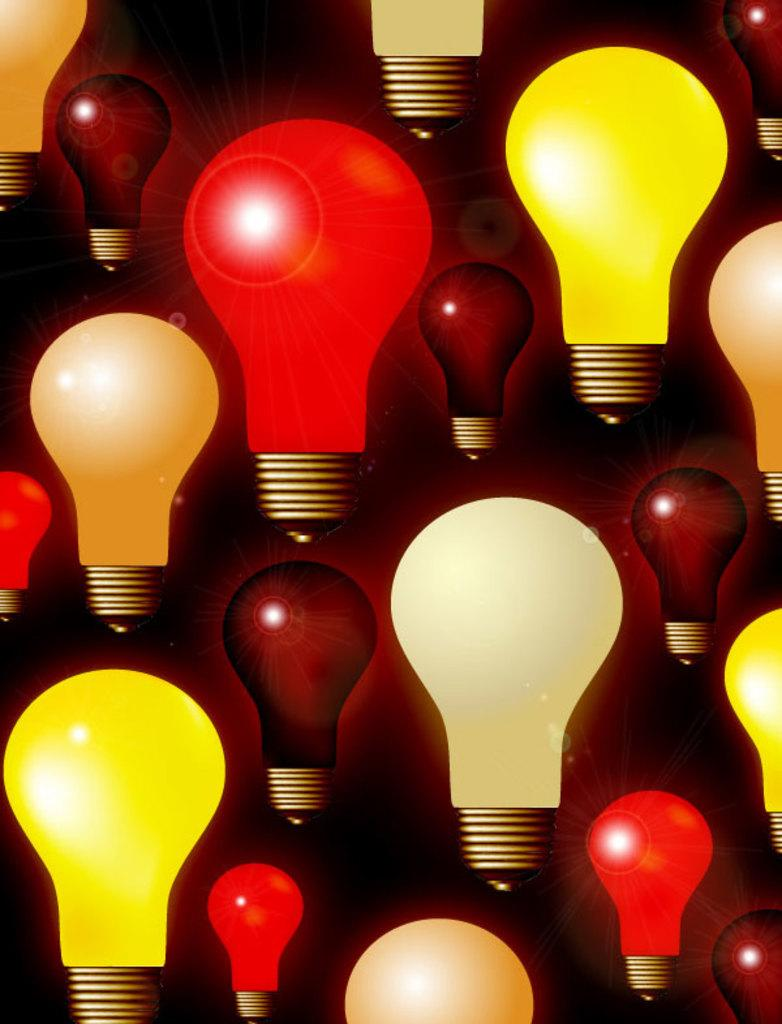What type of image is being described? The image is an animated picture. What objects can be seen in the image? There are colorful bulbs in the image. How does the jelly interact with the colorful bulbs in the image? There is no jelly present in the image, so it cannot interact with the colorful bulbs. 